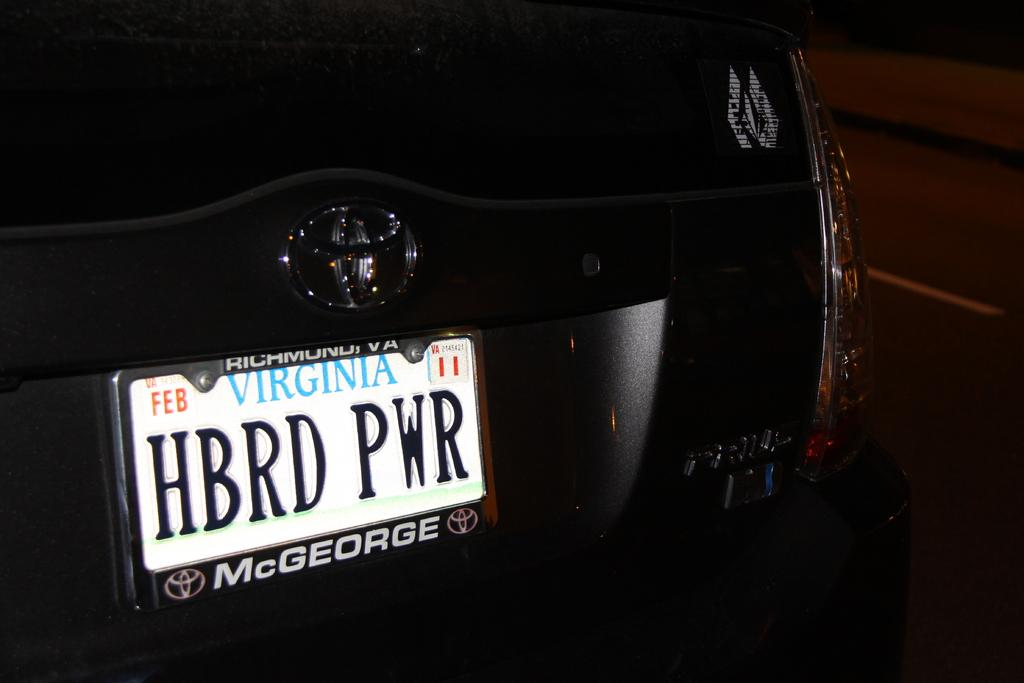<image>
Relay a brief, clear account of the picture shown. Someone from Virginia has a license plate reading HBRD PWR. 